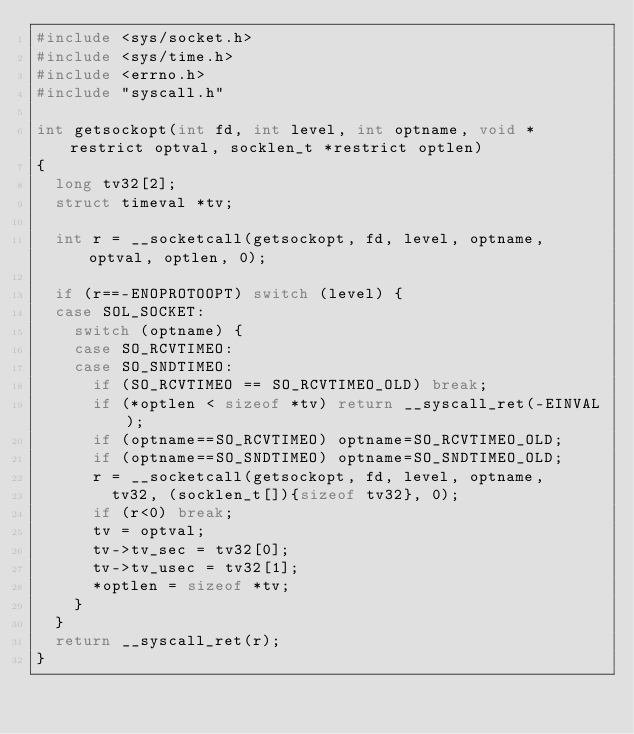Convert code to text. <code><loc_0><loc_0><loc_500><loc_500><_C_>#include <sys/socket.h>
#include <sys/time.h>
#include <errno.h>
#include "syscall.h"

int getsockopt(int fd, int level, int optname, void *restrict optval, socklen_t *restrict optlen)
{
	long tv32[2];
	struct timeval *tv;

	int r = __socketcall(getsockopt, fd, level, optname, optval, optlen, 0);

	if (r==-ENOPROTOOPT) switch (level) {
	case SOL_SOCKET:
		switch (optname) {
		case SO_RCVTIMEO:
		case SO_SNDTIMEO:
			if (SO_RCVTIMEO == SO_RCVTIMEO_OLD) break;
			if (*optlen < sizeof *tv) return __syscall_ret(-EINVAL);
			if (optname==SO_RCVTIMEO) optname=SO_RCVTIMEO_OLD;
			if (optname==SO_SNDTIMEO) optname=SO_SNDTIMEO_OLD;
			r = __socketcall(getsockopt, fd, level, optname,
				tv32, (socklen_t[]){sizeof tv32}, 0);
			if (r<0) break;
			tv = optval;
			tv->tv_sec = tv32[0];
			tv->tv_usec = tv32[1];
			*optlen = sizeof *tv;
		}
	}
	return __syscall_ret(r);
}
</code> 